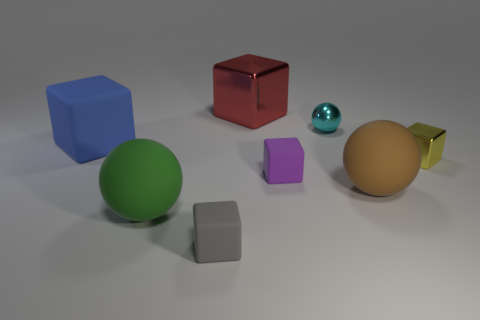What might be the purpose of showcasing these objects together? The objects in the image might be part of a study on light and shadow, an illustration of 3D modeling, or perhaps an artistic composition emphasizing color contrast and geometric forms. 